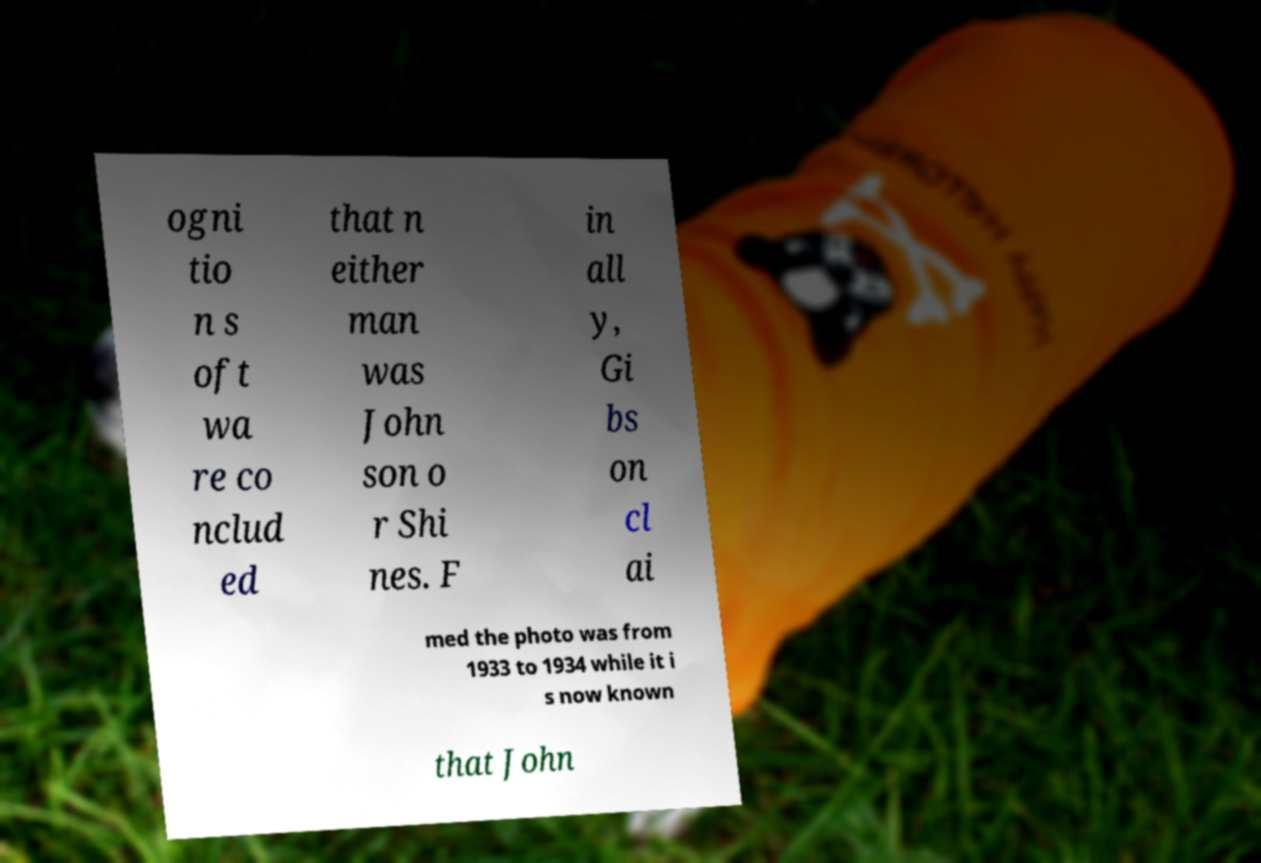Can you read and provide the text displayed in the image?This photo seems to have some interesting text. Can you extract and type it out for me? ogni tio n s oft wa re co nclud ed that n either man was John son o r Shi nes. F in all y, Gi bs on cl ai med the photo was from 1933 to 1934 while it i s now known that John 